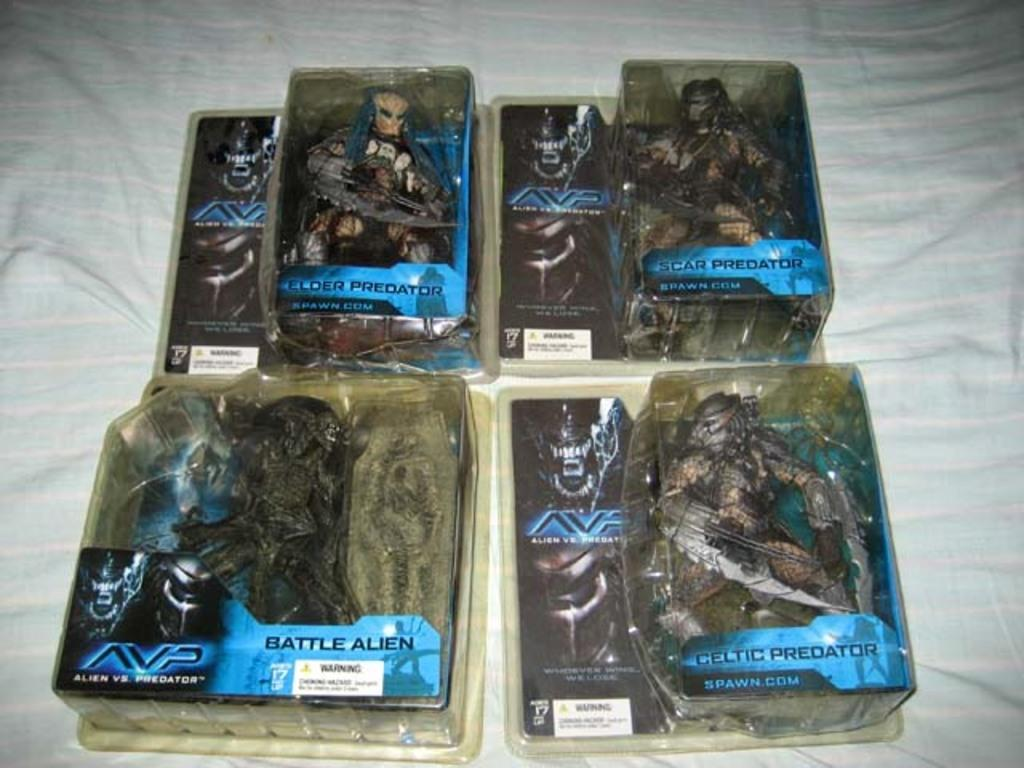What objects are present in the image? There are boxes in the image. What can be seen on the boxes? There is writing on the boxes. What is placed under the boxes? There is a cloth under the boxes. What type of support can be seen at the party in the image? There is no mention of a party or any support in the image; it only features boxes with writing on them and a cloth underneath. 